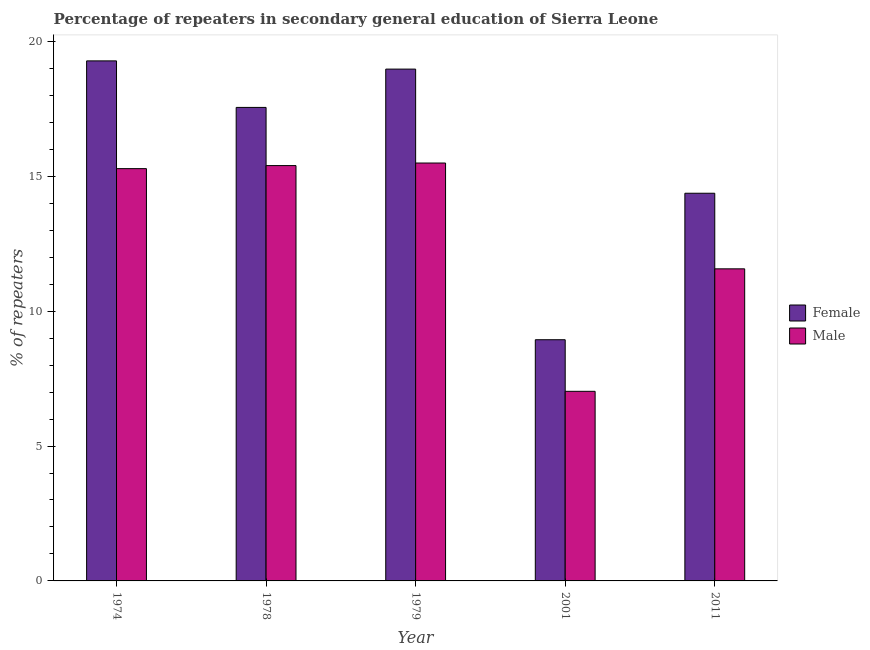How many different coloured bars are there?
Give a very brief answer. 2. How many groups of bars are there?
Offer a terse response. 5. Are the number of bars on each tick of the X-axis equal?
Your response must be concise. Yes. How many bars are there on the 2nd tick from the left?
Give a very brief answer. 2. How many bars are there on the 4th tick from the right?
Keep it short and to the point. 2. What is the label of the 2nd group of bars from the left?
Provide a succinct answer. 1978. What is the percentage of male repeaters in 1979?
Provide a succinct answer. 15.49. Across all years, what is the maximum percentage of female repeaters?
Give a very brief answer. 19.28. Across all years, what is the minimum percentage of male repeaters?
Provide a succinct answer. 7.03. In which year was the percentage of female repeaters maximum?
Provide a succinct answer. 1974. What is the total percentage of female repeaters in the graph?
Your answer should be compact. 79.12. What is the difference between the percentage of male repeaters in 2001 and that in 2011?
Make the answer very short. -4.54. What is the difference between the percentage of male repeaters in 2001 and the percentage of female repeaters in 1979?
Ensure brevity in your answer.  -8.46. What is the average percentage of male repeaters per year?
Ensure brevity in your answer.  12.95. In the year 1974, what is the difference between the percentage of male repeaters and percentage of female repeaters?
Your answer should be compact. 0. In how many years, is the percentage of male repeaters greater than 11 %?
Provide a short and direct response. 4. What is the ratio of the percentage of male repeaters in 1974 to that in 2011?
Your answer should be very brief. 1.32. What is the difference between the highest and the second highest percentage of female repeaters?
Provide a short and direct response. 0.3. What is the difference between the highest and the lowest percentage of male repeaters?
Ensure brevity in your answer.  8.46. Are all the bars in the graph horizontal?
Provide a succinct answer. No. How many years are there in the graph?
Your answer should be compact. 5. What is the difference between two consecutive major ticks on the Y-axis?
Provide a short and direct response. 5. Does the graph contain any zero values?
Offer a terse response. No. What is the title of the graph?
Provide a short and direct response. Percentage of repeaters in secondary general education of Sierra Leone. What is the label or title of the Y-axis?
Your response must be concise. % of repeaters. What is the % of repeaters in Female in 1974?
Your answer should be very brief. 19.28. What is the % of repeaters in Male in 1974?
Offer a terse response. 15.28. What is the % of repeaters in Female in 1978?
Your answer should be very brief. 17.55. What is the % of repeaters in Male in 1978?
Offer a terse response. 15.4. What is the % of repeaters of Female in 1979?
Offer a terse response. 18.97. What is the % of repeaters of Male in 1979?
Your answer should be very brief. 15.49. What is the % of repeaters of Female in 2001?
Provide a succinct answer. 8.94. What is the % of repeaters of Male in 2001?
Make the answer very short. 7.03. What is the % of repeaters of Female in 2011?
Offer a terse response. 14.37. What is the % of repeaters in Male in 2011?
Give a very brief answer. 11.57. Across all years, what is the maximum % of repeaters in Female?
Provide a succinct answer. 19.28. Across all years, what is the maximum % of repeaters of Male?
Keep it short and to the point. 15.49. Across all years, what is the minimum % of repeaters in Female?
Keep it short and to the point. 8.94. Across all years, what is the minimum % of repeaters of Male?
Give a very brief answer. 7.03. What is the total % of repeaters of Female in the graph?
Provide a short and direct response. 79.12. What is the total % of repeaters of Male in the graph?
Your answer should be compact. 64.77. What is the difference between the % of repeaters of Female in 1974 and that in 1978?
Your response must be concise. 1.72. What is the difference between the % of repeaters in Male in 1974 and that in 1978?
Ensure brevity in your answer.  -0.11. What is the difference between the % of repeaters of Female in 1974 and that in 1979?
Keep it short and to the point. 0.3. What is the difference between the % of repeaters in Male in 1974 and that in 1979?
Provide a succinct answer. -0.21. What is the difference between the % of repeaters in Female in 1974 and that in 2001?
Offer a terse response. 10.34. What is the difference between the % of repeaters of Male in 1974 and that in 2001?
Your response must be concise. 8.25. What is the difference between the % of repeaters of Female in 1974 and that in 2011?
Your answer should be very brief. 4.91. What is the difference between the % of repeaters of Male in 1974 and that in 2011?
Your response must be concise. 3.71. What is the difference between the % of repeaters of Female in 1978 and that in 1979?
Keep it short and to the point. -1.42. What is the difference between the % of repeaters of Male in 1978 and that in 1979?
Your answer should be very brief. -0.09. What is the difference between the % of repeaters in Female in 1978 and that in 2001?
Offer a very short reply. 8.61. What is the difference between the % of repeaters in Male in 1978 and that in 2001?
Make the answer very short. 8.37. What is the difference between the % of repeaters in Female in 1978 and that in 2011?
Keep it short and to the point. 3.18. What is the difference between the % of repeaters in Male in 1978 and that in 2011?
Keep it short and to the point. 3.83. What is the difference between the % of repeaters in Female in 1979 and that in 2001?
Your response must be concise. 10.03. What is the difference between the % of repeaters in Male in 1979 and that in 2001?
Provide a short and direct response. 8.46. What is the difference between the % of repeaters in Female in 1979 and that in 2011?
Ensure brevity in your answer.  4.6. What is the difference between the % of repeaters in Male in 1979 and that in 2011?
Your answer should be compact. 3.92. What is the difference between the % of repeaters in Female in 2001 and that in 2011?
Provide a succinct answer. -5.43. What is the difference between the % of repeaters in Male in 2001 and that in 2011?
Make the answer very short. -4.54. What is the difference between the % of repeaters in Female in 1974 and the % of repeaters in Male in 1978?
Give a very brief answer. 3.88. What is the difference between the % of repeaters in Female in 1974 and the % of repeaters in Male in 1979?
Give a very brief answer. 3.79. What is the difference between the % of repeaters in Female in 1974 and the % of repeaters in Male in 2001?
Your answer should be compact. 12.25. What is the difference between the % of repeaters of Female in 1974 and the % of repeaters of Male in 2011?
Provide a succinct answer. 7.71. What is the difference between the % of repeaters in Female in 1978 and the % of repeaters in Male in 1979?
Offer a very short reply. 2.06. What is the difference between the % of repeaters in Female in 1978 and the % of repeaters in Male in 2001?
Ensure brevity in your answer.  10.52. What is the difference between the % of repeaters in Female in 1978 and the % of repeaters in Male in 2011?
Your response must be concise. 5.98. What is the difference between the % of repeaters in Female in 1979 and the % of repeaters in Male in 2001?
Offer a terse response. 11.94. What is the difference between the % of repeaters of Female in 1979 and the % of repeaters of Male in 2011?
Your answer should be compact. 7.4. What is the difference between the % of repeaters of Female in 2001 and the % of repeaters of Male in 2011?
Your answer should be compact. -2.63. What is the average % of repeaters in Female per year?
Give a very brief answer. 15.82. What is the average % of repeaters of Male per year?
Your answer should be compact. 12.95. In the year 1974, what is the difference between the % of repeaters in Female and % of repeaters in Male?
Make the answer very short. 3.99. In the year 1978, what is the difference between the % of repeaters of Female and % of repeaters of Male?
Your response must be concise. 2.16. In the year 1979, what is the difference between the % of repeaters in Female and % of repeaters in Male?
Make the answer very short. 3.48. In the year 2001, what is the difference between the % of repeaters in Female and % of repeaters in Male?
Provide a short and direct response. 1.91. In the year 2011, what is the difference between the % of repeaters in Female and % of repeaters in Male?
Your answer should be very brief. 2.8. What is the ratio of the % of repeaters of Female in 1974 to that in 1978?
Provide a short and direct response. 1.1. What is the ratio of the % of repeaters in Male in 1974 to that in 1978?
Your answer should be compact. 0.99. What is the ratio of the % of repeaters of Female in 1974 to that in 1979?
Give a very brief answer. 1.02. What is the ratio of the % of repeaters in Male in 1974 to that in 1979?
Your answer should be compact. 0.99. What is the ratio of the % of repeaters in Female in 1974 to that in 2001?
Make the answer very short. 2.16. What is the ratio of the % of repeaters of Male in 1974 to that in 2001?
Offer a terse response. 2.17. What is the ratio of the % of repeaters of Female in 1974 to that in 2011?
Offer a very short reply. 1.34. What is the ratio of the % of repeaters in Male in 1974 to that in 2011?
Ensure brevity in your answer.  1.32. What is the ratio of the % of repeaters of Female in 1978 to that in 1979?
Give a very brief answer. 0.93. What is the ratio of the % of repeaters of Male in 1978 to that in 1979?
Keep it short and to the point. 0.99. What is the ratio of the % of repeaters in Female in 1978 to that in 2001?
Ensure brevity in your answer.  1.96. What is the ratio of the % of repeaters in Male in 1978 to that in 2001?
Your response must be concise. 2.19. What is the ratio of the % of repeaters of Female in 1978 to that in 2011?
Offer a very short reply. 1.22. What is the ratio of the % of repeaters in Male in 1978 to that in 2011?
Ensure brevity in your answer.  1.33. What is the ratio of the % of repeaters in Female in 1979 to that in 2001?
Keep it short and to the point. 2.12. What is the ratio of the % of repeaters of Male in 1979 to that in 2001?
Keep it short and to the point. 2.2. What is the ratio of the % of repeaters in Female in 1979 to that in 2011?
Ensure brevity in your answer.  1.32. What is the ratio of the % of repeaters in Male in 1979 to that in 2011?
Ensure brevity in your answer.  1.34. What is the ratio of the % of repeaters in Female in 2001 to that in 2011?
Offer a very short reply. 0.62. What is the ratio of the % of repeaters in Male in 2001 to that in 2011?
Offer a very short reply. 0.61. What is the difference between the highest and the second highest % of repeaters of Female?
Provide a succinct answer. 0.3. What is the difference between the highest and the second highest % of repeaters in Male?
Give a very brief answer. 0.09. What is the difference between the highest and the lowest % of repeaters of Female?
Offer a very short reply. 10.34. What is the difference between the highest and the lowest % of repeaters of Male?
Your response must be concise. 8.46. 